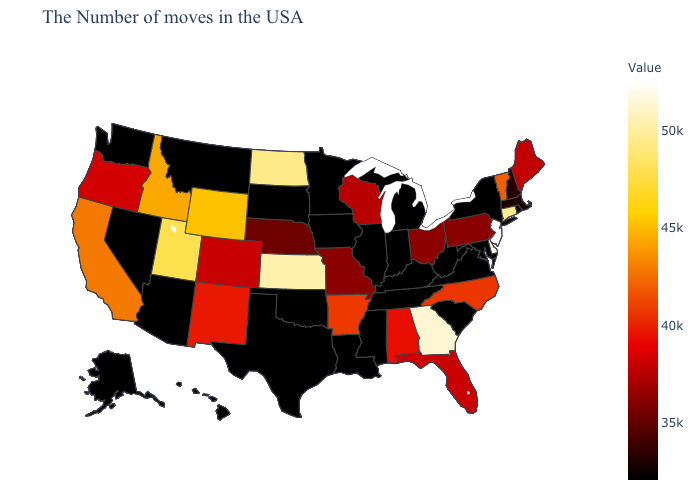Which states hav the highest value in the West?
Concise answer only. Utah. Which states have the lowest value in the USA?
Be succinct. Rhode Island, New York, Maryland, Virginia, South Carolina, West Virginia, Michigan, Kentucky, Indiana, Tennessee, Illinois, Mississippi, Louisiana, Minnesota, Iowa, Oklahoma, Texas, South Dakota, Montana, Arizona, Nevada, Washington, Alaska. Among the states that border Massachusetts , which have the highest value?
Write a very short answer. Connecticut. Does New Jersey have the highest value in the USA?
Be succinct. Yes. Which states have the highest value in the USA?
Be succinct. New Jersey. Does New York have the highest value in the Northeast?
Write a very short answer. No. Does Missouri have the lowest value in the MidWest?
Keep it brief. No. 